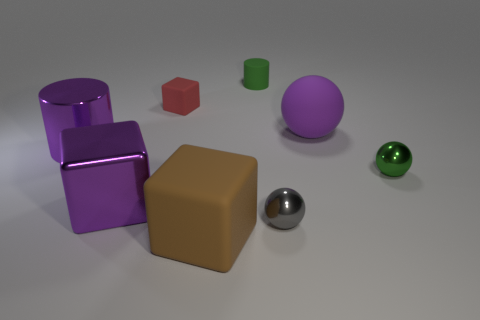What is the material of the tiny ball that is the same color as the rubber cylinder? The tiny ball appears to have a reflective surface similar to metals, indicating that it could likely be made of a polished metal. 